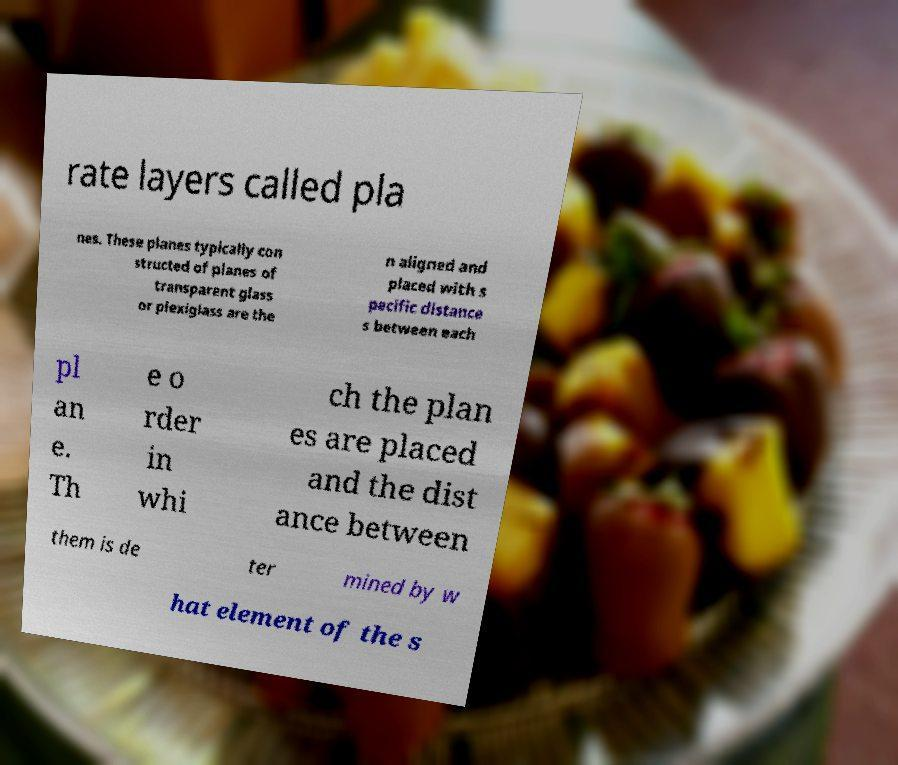I need the written content from this picture converted into text. Can you do that? rate layers called pla nes. These planes typically con structed of planes of transparent glass or plexiglass are the n aligned and placed with s pecific distance s between each pl an e. Th e o rder in whi ch the plan es are placed and the dist ance between them is de ter mined by w hat element of the s 